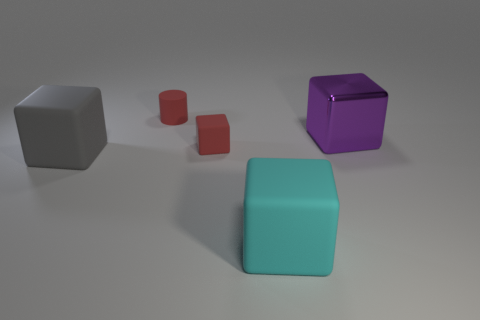Is the color of the small cylinder the same as the tiny matte block?
Provide a short and direct response. Yes. How many spheres are either small red things or cyan rubber things?
Your answer should be very brief. 0. How many other objects are there of the same material as the large purple thing?
Keep it short and to the point. 0. There is a tiny red matte thing behind the large metal cube; what is its shape?
Offer a terse response. Cylinder. What material is the large thing that is behind the cube to the left of the small rubber cube made of?
Your answer should be very brief. Metal. Is the number of matte things in front of the matte cylinder greater than the number of tiny brown cylinders?
Provide a succinct answer. Yes. How many other objects are the same color as the large metallic object?
Keep it short and to the point. 0. What is the shape of the cyan thing that is the same size as the purple metal cube?
Your answer should be compact. Cube. What number of large metal cubes are in front of the small red matte cylinder to the left of the small red matte object that is in front of the big purple metallic thing?
Your answer should be compact. 1. What number of metal objects are small red cylinders or big red cylinders?
Offer a terse response. 0. 